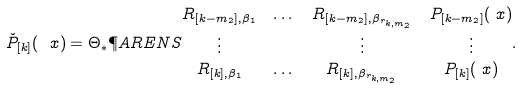Convert formula to latex. <formula><loc_0><loc_0><loc_500><loc_500>\check { P } _ { [ k ] } ( \ x ) & = \Theta _ { * } \P A R E N S { \begin{matrix} R _ { [ k - m _ { 2 } ] , \beta _ { 1 } } & \dots & R _ { [ k - m _ { 2 } ] , \beta _ { r _ { k , m _ { 2 } } } } & P _ { [ k - m _ { 2 } ] } ( \ x ) \\ \vdots & & \vdots & \vdots \\ R _ { [ k ] , \beta _ { 1 } } & \dots & R _ { [ k ] , \beta _ { r _ { k , m _ { 2 } } } } & P _ { [ k ] } ( \ x ) \end{matrix} } .</formula> 